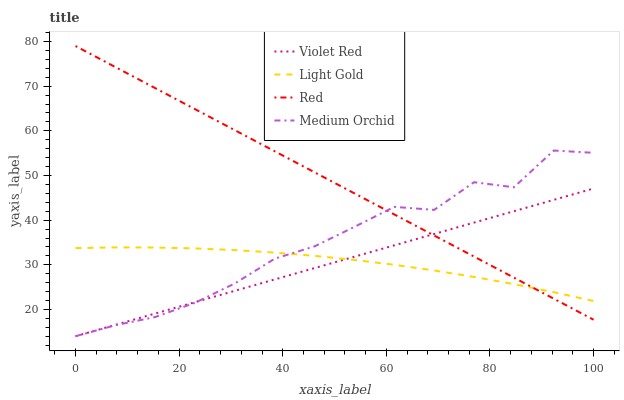Does Light Gold have the minimum area under the curve?
Answer yes or no. Yes. Does Red have the maximum area under the curve?
Answer yes or no. Yes. Does Medium Orchid have the minimum area under the curve?
Answer yes or no. No. Does Medium Orchid have the maximum area under the curve?
Answer yes or no. No. Is Violet Red the smoothest?
Answer yes or no. Yes. Is Medium Orchid the roughest?
Answer yes or no. Yes. Is Light Gold the smoothest?
Answer yes or no. No. Is Light Gold the roughest?
Answer yes or no. No. Does Violet Red have the lowest value?
Answer yes or no. Yes. Does Light Gold have the lowest value?
Answer yes or no. No. Does Red have the highest value?
Answer yes or no. Yes. Does Medium Orchid have the highest value?
Answer yes or no. No. Does Light Gold intersect Medium Orchid?
Answer yes or no. Yes. Is Light Gold less than Medium Orchid?
Answer yes or no. No. Is Light Gold greater than Medium Orchid?
Answer yes or no. No. 